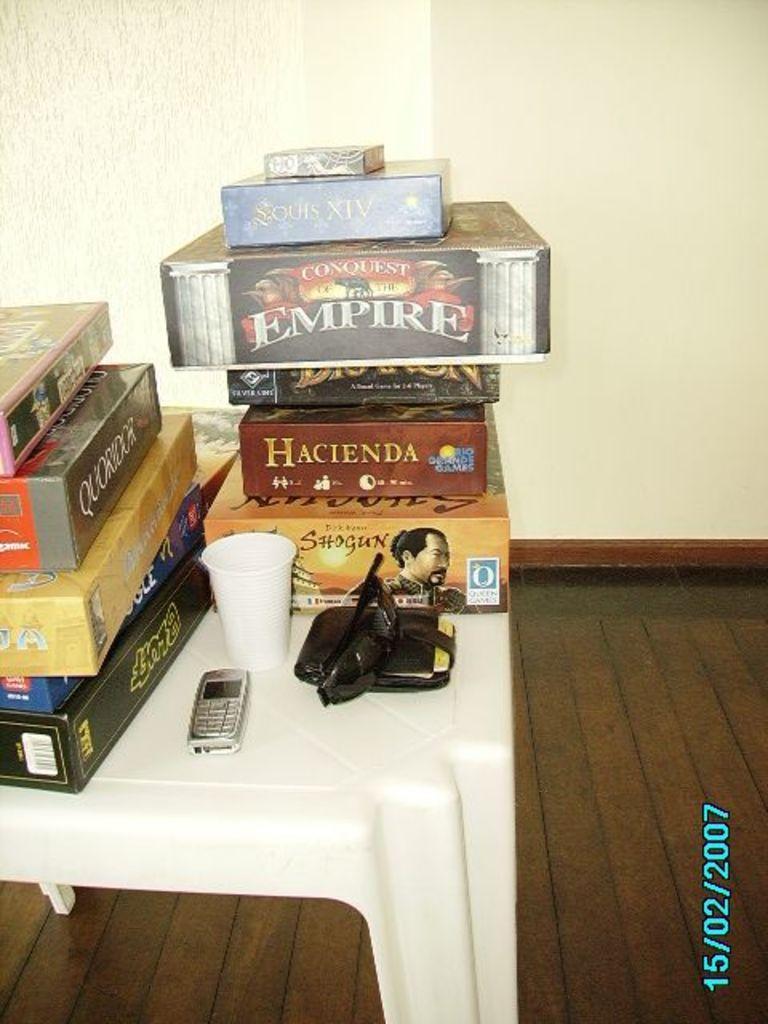Please provide a concise description of this image. In this picture there is table and on the table there are boxes, glass, sunglasses, wallet and a mobile phone. There is date to the right corner of the image. In the background there is wall and the floor is furnished with wood. 